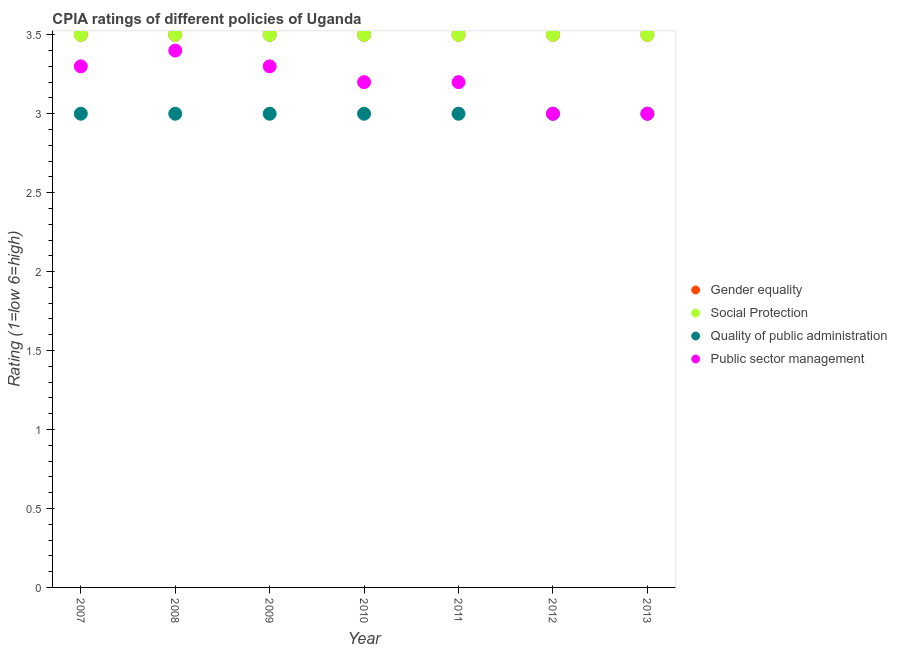In which year was the cpia rating of social protection maximum?
Offer a terse response. 2007. In which year was the cpia rating of social protection minimum?
Make the answer very short. 2007. What is the total cpia rating of quality of public administration in the graph?
Keep it short and to the point. 21. What is the difference between the cpia rating of quality of public administration in 2011 and that in 2012?
Offer a terse response. 0. What is the ratio of the cpia rating of public sector management in 2010 to that in 2011?
Your answer should be very brief. 1. Is the sum of the cpia rating of quality of public administration in 2007 and 2008 greater than the maximum cpia rating of public sector management across all years?
Ensure brevity in your answer.  Yes. Is it the case that in every year, the sum of the cpia rating of social protection and cpia rating of public sector management is greater than the sum of cpia rating of gender equality and cpia rating of quality of public administration?
Provide a short and direct response. No. Is it the case that in every year, the sum of the cpia rating of gender equality and cpia rating of social protection is greater than the cpia rating of quality of public administration?
Offer a terse response. Yes. Is the cpia rating of gender equality strictly less than the cpia rating of public sector management over the years?
Keep it short and to the point. No. What is the difference between two consecutive major ticks on the Y-axis?
Provide a short and direct response. 0.5. How are the legend labels stacked?
Your answer should be compact. Vertical. What is the title of the graph?
Offer a terse response. CPIA ratings of different policies of Uganda. Does "Miscellaneous expenses" appear as one of the legend labels in the graph?
Your response must be concise. No. What is the label or title of the X-axis?
Provide a short and direct response. Year. What is the label or title of the Y-axis?
Keep it short and to the point. Rating (1=low 6=high). What is the Rating (1=low 6=high) in Gender equality in 2008?
Make the answer very short. 3.5. What is the Rating (1=low 6=high) of Quality of public administration in 2008?
Make the answer very short. 3. What is the Rating (1=low 6=high) in Public sector management in 2008?
Provide a short and direct response. 3.4. What is the Rating (1=low 6=high) of Gender equality in 2009?
Provide a short and direct response. 3.5. What is the Rating (1=low 6=high) of Social Protection in 2009?
Provide a succinct answer. 3.5. What is the Rating (1=low 6=high) in Quality of public administration in 2009?
Offer a terse response. 3. What is the Rating (1=low 6=high) in Public sector management in 2009?
Provide a short and direct response. 3.3. What is the Rating (1=low 6=high) of Social Protection in 2010?
Ensure brevity in your answer.  3.5. What is the Rating (1=low 6=high) of Public sector management in 2010?
Provide a short and direct response. 3.2. What is the Rating (1=low 6=high) in Gender equality in 2011?
Provide a succinct answer. 3.5. What is the Rating (1=low 6=high) in Quality of public administration in 2011?
Offer a terse response. 3. What is the Rating (1=low 6=high) in Public sector management in 2011?
Your answer should be compact. 3.2. What is the Rating (1=low 6=high) of Public sector management in 2012?
Give a very brief answer. 3. What is the Rating (1=low 6=high) in Gender equality in 2013?
Provide a short and direct response. 3.5. Across all years, what is the maximum Rating (1=low 6=high) in Gender equality?
Make the answer very short. 3.5. Across all years, what is the maximum Rating (1=low 6=high) in Quality of public administration?
Make the answer very short. 3. Across all years, what is the maximum Rating (1=low 6=high) in Public sector management?
Keep it short and to the point. 3.4. Across all years, what is the minimum Rating (1=low 6=high) of Quality of public administration?
Your response must be concise. 3. Across all years, what is the minimum Rating (1=low 6=high) of Public sector management?
Offer a very short reply. 3. What is the total Rating (1=low 6=high) of Social Protection in the graph?
Provide a short and direct response. 24.5. What is the total Rating (1=low 6=high) of Public sector management in the graph?
Ensure brevity in your answer.  22.4. What is the difference between the Rating (1=low 6=high) of Social Protection in 2007 and that in 2008?
Make the answer very short. 0. What is the difference between the Rating (1=low 6=high) in Quality of public administration in 2007 and that in 2008?
Your response must be concise. 0. What is the difference between the Rating (1=low 6=high) of Gender equality in 2007 and that in 2009?
Offer a very short reply. 0. What is the difference between the Rating (1=low 6=high) of Social Protection in 2007 and that in 2009?
Your response must be concise. 0. What is the difference between the Rating (1=low 6=high) of Social Protection in 2007 and that in 2010?
Offer a very short reply. 0. What is the difference between the Rating (1=low 6=high) in Quality of public administration in 2007 and that in 2010?
Your answer should be compact. 0. What is the difference between the Rating (1=low 6=high) in Public sector management in 2007 and that in 2010?
Your response must be concise. 0.1. What is the difference between the Rating (1=low 6=high) of Gender equality in 2007 and that in 2011?
Offer a very short reply. 0. What is the difference between the Rating (1=low 6=high) of Quality of public administration in 2007 and that in 2011?
Provide a short and direct response. 0. What is the difference between the Rating (1=low 6=high) of Social Protection in 2007 and that in 2012?
Offer a very short reply. 0. What is the difference between the Rating (1=low 6=high) of Public sector management in 2007 and that in 2012?
Keep it short and to the point. 0.3. What is the difference between the Rating (1=low 6=high) of Gender equality in 2008 and that in 2009?
Your answer should be compact. 0. What is the difference between the Rating (1=low 6=high) of Social Protection in 2008 and that in 2009?
Keep it short and to the point. 0. What is the difference between the Rating (1=low 6=high) in Public sector management in 2008 and that in 2009?
Your response must be concise. 0.1. What is the difference between the Rating (1=low 6=high) of Quality of public administration in 2008 and that in 2010?
Give a very brief answer. 0. What is the difference between the Rating (1=low 6=high) of Public sector management in 2008 and that in 2010?
Provide a succinct answer. 0.2. What is the difference between the Rating (1=low 6=high) in Gender equality in 2008 and that in 2011?
Offer a terse response. 0. What is the difference between the Rating (1=low 6=high) of Social Protection in 2008 and that in 2011?
Keep it short and to the point. 0. What is the difference between the Rating (1=low 6=high) in Quality of public administration in 2008 and that in 2011?
Your response must be concise. 0. What is the difference between the Rating (1=low 6=high) of Gender equality in 2008 and that in 2012?
Your response must be concise. 0. What is the difference between the Rating (1=low 6=high) of Social Protection in 2008 and that in 2012?
Keep it short and to the point. 0. What is the difference between the Rating (1=low 6=high) in Social Protection in 2008 and that in 2013?
Provide a short and direct response. 0. What is the difference between the Rating (1=low 6=high) in Gender equality in 2009 and that in 2010?
Your answer should be very brief. 0. What is the difference between the Rating (1=low 6=high) of Social Protection in 2009 and that in 2010?
Your response must be concise. 0. What is the difference between the Rating (1=low 6=high) of Gender equality in 2009 and that in 2011?
Your answer should be compact. 0. What is the difference between the Rating (1=low 6=high) in Social Protection in 2009 and that in 2011?
Ensure brevity in your answer.  0. What is the difference between the Rating (1=low 6=high) in Quality of public administration in 2009 and that in 2011?
Offer a terse response. 0. What is the difference between the Rating (1=low 6=high) in Gender equality in 2009 and that in 2012?
Ensure brevity in your answer.  0. What is the difference between the Rating (1=low 6=high) in Social Protection in 2009 and that in 2012?
Offer a terse response. 0. What is the difference between the Rating (1=low 6=high) of Quality of public administration in 2009 and that in 2012?
Give a very brief answer. 0. What is the difference between the Rating (1=low 6=high) in Gender equality in 2009 and that in 2013?
Your answer should be very brief. 0. What is the difference between the Rating (1=low 6=high) of Public sector management in 2009 and that in 2013?
Give a very brief answer. 0.3. What is the difference between the Rating (1=low 6=high) in Gender equality in 2010 and that in 2011?
Your answer should be compact. 0. What is the difference between the Rating (1=low 6=high) in Social Protection in 2010 and that in 2011?
Keep it short and to the point. 0. What is the difference between the Rating (1=low 6=high) of Public sector management in 2010 and that in 2011?
Your answer should be very brief. 0. What is the difference between the Rating (1=low 6=high) in Gender equality in 2010 and that in 2012?
Provide a short and direct response. 0. What is the difference between the Rating (1=low 6=high) in Social Protection in 2010 and that in 2012?
Offer a terse response. 0. What is the difference between the Rating (1=low 6=high) in Public sector management in 2010 and that in 2012?
Make the answer very short. 0.2. What is the difference between the Rating (1=low 6=high) of Social Protection in 2010 and that in 2013?
Offer a very short reply. 0. What is the difference between the Rating (1=low 6=high) of Public sector management in 2010 and that in 2013?
Offer a terse response. 0.2. What is the difference between the Rating (1=low 6=high) in Gender equality in 2011 and that in 2012?
Your answer should be very brief. 0. What is the difference between the Rating (1=low 6=high) of Social Protection in 2011 and that in 2012?
Keep it short and to the point. 0. What is the difference between the Rating (1=low 6=high) of Quality of public administration in 2011 and that in 2012?
Ensure brevity in your answer.  0. What is the difference between the Rating (1=low 6=high) of Public sector management in 2011 and that in 2012?
Make the answer very short. 0.2. What is the difference between the Rating (1=low 6=high) of Gender equality in 2011 and that in 2013?
Offer a very short reply. 0. What is the difference between the Rating (1=low 6=high) in Social Protection in 2011 and that in 2013?
Your answer should be very brief. 0. What is the difference between the Rating (1=low 6=high) in Public sector management in 2011 and that in 2013?
Your answer should be very brief. 0.2. What is the difference between the Rating (1=low 6=high) in Gender equality in 2012 and that in 2013?
Keep it short and to the point. 0. What is the difference between the Rating (1=low 6=high) in Quality of public administration in 2012 and that in 2013?
Provide a short and direct response. 0. What is the difference between the Rating (1=low 6=high) in Social Protection in 2007 and the Rating (1=low 6=high) in Quality of public administration in 2008?
Give a very brief answer. 0.5. What is the difference between the Rating (1=low 6=high) in Social Protection in 2007 and the Rating (1=low 6=high) in Public sector management in 2008?
Give a very brief answer. 0.1. What is the difference between the Rating (1=low 6=high) of Quality of public administration in 2007 and the Rating (1=low 6=high) of Public sector management in 2008?
Make the answer very short. -0.4. What is the difference between the Rating (1=low 6=high) in Gender equality in 2007 and the Rating (1=low 6=high) in Quality of public administration in 2009?
Give a very brief answer. 0.5. What is the difference between the Rating (1=low 6=high) of Social Protection in 2007 and the Rating (1=low 6=high) of Quality of public administration in 2009?
Offer a terse response. 0.5. What is the difference between the Rating (1=low 6=high) in Gender equality in 2007 and the Rating (1=low 6=high) in Quality of public administration in 2010?
Give a very brief answer. 0.5. What is the difference between the Rating (1=low 6=high) in Social Protection in 2007 and the Rating (1=low 6=high) in Public sector management in 2010?
Offer a very short reply. 0.3. What is the difference between the Rating (1=low 6=high) of Quality of public administration in 2007 and the Rating (1=low 6=high) of Public sector management in 2010?
Provide a succinct answer. -0.2. What is the difference between the Rating (1=low 6=high) of Gender equality in 2007 and the Rating (1=low 6=high) of Quality of public administration in 2011?
Offer a very short reply. 0.5. What is the difference between the Rating (1=low 6=high) in Social Protection in 2007 and the Rating (1=low 6=high) in Public sector management in 2011?
Offer a terse response. 0.3. What is the difference between the Rating (1=low 6=high) in Social Protection in 2007 and the Rating (1=low 6=high) in Quality of public administration in 2012?
Ensure brevity in your answer.  0.5. What is the difference between the Rating (1=low 6=high) in Social Protection in 2007 and the Rating (1=low 6=high) in Public sector management in 2012?
Offer a terse response. 0.5. What is the difference between the Rating (1=low 6=high) of Gender equality in 2007 and the Rating (1=low 6=high) of Social Protection in 2013?
Offer a terse response. 0. What is the difference between the Rating (1=low 6=high) in Gender equality in 2007 and the Rating (1=low 6=high) in Public sector management in 2013?
Your response must be concise. 0.5. What is the difference between the Rating (1=low 6=high) of Quality of public administration in 2007 and the Rating (1=low 6=high) of Public sector management in 2013?
Your answer should be very brief. 0. What is the difference between the Rating (1=low 6=high) in Gender equality in 2008 and the Rating (1=low 6=high) in Social Protection in 2009?
Keep it short and to the point. 0. What is the difference between the Rating (1=low 6=high) of Gender equality in 2008 and the Rating (1=low 6=high) of Quality of public administration in 2009?
Keep it short and to the point. 0.5. What is the difference between the Rating (1=low 6=high) of Gender equality in 2008 and the Rating (1=low 6=high) of Quality of public administration in 2010?
Provide a succinct answer. 0.5. What is the difference between the Rating (1=low 6=high) in Gender equality in 2008 and the Rating (1=low 6=high) in Public sector management in 2010?
Provide a short and direct response. 0.3. What is the difference between the Rating (1=low 6=high) of Social Protection in 2008 and the Rating (1=low 6=high) of Quality of public administration in 2010?
Offer a very short reply. 0.5. What is the difference between the Rating (1=low 6=high) of Quality of public administration in 2008 and the Rating (1=low 6=high) of Public sector management in 2010?
Give a very brief answer. -0.2. What is the difference between the Rating (1=low 6=high) of Gender equality in 2008 and the Rating (1=low 6=high) of Social Protection in 2011?
Your answer should be very brief. 0. What is the difference between the Rating (1=low 6=high) of Gender equality in 2008 and the Rating (1=low 6=high) of Public sector management in 2011?
Keep it short and to the point. 0.3. What is the difference between the Rating (1=low 6=high) of Social Protection in 2008 and the Rating (1=low 6=high) of Quality of public administration in 2011?
Provide a short and direct response. 0.5. What is the difference between the Rating (1=low 6=high) in Social Protection in 2008 and the Rating (1=low 6=high) in Public sector management in 2011?
Your response must be concise. 0.3. What is the difference between the Rating (1=low 6=high) in Gender equality in 2008 and the Rating (1=low 6=high) in Social Protection in 2012?
Offer a very short reply. 0. What is the difference between the Rating (1=low 6=high) of Gender equality in 2008 and the Rating (1=low 6=high) of Quality of public administration in 2012?
Ensure brevity in your answer.  0.5. What is the difference between the Rating (1=low 6=high) in Gender equality in 2008 and the Rating (1=low 6=high) in Public sector management in 2012?
Offer a very short reply. 0.5. What is the difference between the Rating (1=low 6=high) in Social Protection in 2008 and the Rating (1=low 6=high) in Public sector management in 2012?
Your answer should be very brief. 0.5. What is the difference between the Rating (1=low 6=high) of Quality of public administration in 2008 and the Rating (1=low 6=high) of Public sector management in 2012?
Offer a terse response. 0. What is the difference between the Rating (1=low 6=high) in Gender equality in 2008 and the Rating (1=low 6=high) in Quality of public administration in 2013?
Provide a short and direct response. 0.5. What is the difference between the Rating (1=low 6=high) of Gender equality in 2008 and the Rating (1=low 6=high) of Public sector management in 2013?
Provide a succinct answer. 0.5. What is the difference between the Rating (1=low 6=high) of Social Protection in 2008 and the Rating (1=low 6=high) of Public sector management in 2013?
Make the answer very short. 0.5. What is the difference between the Rating (1=low 6=high) of Quality of public administration in 2008 and the Rating (1=low 6=high) of Public sector management in 2013?
Your answer should be compact. 0. What is the difference between the Rating (1=low 6=high) in Gender equality in 2009 and the Rating (1=low 6=high) in Social Protection in 2010?
Offer a terse response. 0. What is the difference between the Rating (1=low 6=high) of Gender equality in 2009 and the Rating (1=low 6=high) of Quality of public administration in 2010?
Provide a succinct answer. 0.5. What is the difference between the Rating (1=low 6=high) of Gender equality in 2009 and the Rating (1=low 6=high) of Public sector management in 2010?
Provide a short and direct response. 0.3. What is the difference between the Rating (1=low 6=high) of Social Protection in 2009 and the Rating (1=low 6=high) of Public sector management in 2010?
Offer a terse response. 0.3. What is the difference between the Rating (1=low 6=high) of Gender equality in 2009 and the Rating (1=low 6=high) of Social Protection in 2011?
Your answer should be very brief. 0. What is the difference between the Rating (1=low 6=high) in Gender equality in 2009 and the Rating (1=low 6=high) in Quality of public administration in 2011?
Offer a very short reply. 0.5. What is the difference between the Rating (1=low 6=high) of Gender equality in 2009 and the Rating (1=low 6=high) of Public sector management in 2011?
Offer a very short reply. 0.3. What is the difference between the Rating (1=low 6=high) of Social Protection in 2009 and the Rating (1=low 6=high) of Quality of public administration in 2011?
Provide a short and direct response. 0.5. What is the difference between the Rating (1=low 6=high) of Gender equality in 2009 and the Rating (1=low 6=high) of Public sector management in 2012?
Make the answer very short. 0.5. What is the difference between the Rating (1=low 6=high) in Social Protection in 2009 and the Rating (1=low 6=high) in Quality of public administration in 2012?
Make the answer very short. 0.5. What is the difference between the Rating (1=low 6=high) in Social Protection in 2009 and the Rating (1=low 6=high) in Quality of public administration in 2013?
Ensure brevity in your answer.  0.5. What is the difference between the Rating (1=low 6=high) in Gender equality in 2010 and the Rating (1=low 6=high) in Public sector management in 2011?
Your answer should be very brief. 0.3. What is the difference between the Rating (1=low 6=high) of Social Protection in 2010 and the Rating (1=low 6=high) of Public sector management in 2011?
Your answer should be very brief. 0.3. What is the difference between the Rating (1=low 6=high) of Gender equality in 2010 and the Rating (1=low 6=high) of Social Protection in 2012?
Your answer should be very brief. 0. What is the difference between the Rating (1=low 6=high) of Gender equality in 2010 and the Rating (1=low 6=high) of Quality of public administration in 2012?
Your answer should be very brief. 0.5. What is the difference between the Rating (1=low 6=high) of Social Protection in 2010 and the Rating (1=low 6=high) of Quality of public administration in 2012?
Your answer should be compact. 0.5. What is the difference between the Rating (1=low 6=high) of Social Protection in 2010 and the Rating (1=low 6=high) of Public sector management in 2012?
Your answer should be very brief. 0.5. What is the difference between the Rating (1=low 6=high) in Gender equality in 2010 and the Rating (1=low 6=high) in Quality of public administration in 2013?
Your answer should be very brief. 0.5. What is the difference between the Rating (1=low 6=high) of Social Protection in 2010 and the Rating (1=low 6=high) of Public sector management in 2013?
Your answer should be compact. 0.5. What is the difference between the Rating (1=low 6=high) in Gender equality in 2011 and the Rating (1=low 6=high) in Public sector management in 2012?
Make the answer very short. 0.5. What is the difference between the Rating (1=low 6=high) in Social Protection in 2011 and the Rating (1=low 6=high) in Quality of public administration in 2012?
Give a very brief answer. 0.5. What is the difference between the Rating (1=low 6=high) in Social Protection in 2011 and the Rating (1=low 6=high) in Public sector management in 2013?
Provide a short and direct response. 0.5. What is the difference between the Rating (1=low 6=high) of Quality of public administration in 2011 and the Rating (1=low 6=high) of Public sector management in 2013?
Make the answer very short. 0. What is the difference between the Rating (1=low 6=high) in Gender equality in 2012 and the Rating (1=low 6=high) in Social Protection in 2013?
Offer a very short reply. 0. What is the difference between the Rating (1=low 6=high) in Social Protection in 2012 and the Rating (1=low 6=high) in Quality of public administration in 2013?
Make the answer very short. 0.5. What is the difference between the Rating (1=low 6=high) of Quality of public administration in 2012 and the Rating (1=low 6=high) of Public sector management in 2013?
Give a very brief answer. 0. What is the average Rating (1=low 6=high) in Social Protection per year?
Keep it short and to the point. 3.5. What is the average Rating (1=low 6=high) of Quality of public administration per year?
Your answer should be compact. 3. In the year 2007, what is the difference between the Rating (1=low 6=high) of Gender equality and Rating (1=low 6=high) of Social Protection?
Provide a short and direct response. 0. In the year 2007, what is the difference between the Rating (1=low 6=high) in Gender equality and Rating (1=low 6=high) in Public sector management?
Your answer should be very brief. 0.2. In the year 2007, what is the difference between the Rating (1=low 6=high) in Social Protection and Rating (1=low 6=high) in Quality of public administration?
Offer a very short reply. 0.5. In the year 2007, what is the difference between the Rating (1=low 6=high) of Social Protection and Rating (1=low 6=high) of Public sector management?
Give a very brief answer. 0.2. In the year 2007, what is the difference between the Rating (1=low 6=high) of Quality of public administration and Rating (1=low 6=high) of Public sector management?
Your response must be concise. -0.3. In the year 2008, what is the difference between the Rating (1=low 6=high) in Gender equality and Rating (1=low 6=high) in Public sector management?
Provide a succinct answer. 0.1. In the year 2008, what is the difference between the Rating (1=low 6=high) of Social Protection and Rating (1=low 6=high) of Quality of public administration?
Give a very brief answer. 0.5. In the year 2008, what is the difference between the Rating (1=low 6=high) in Quality of public administration and Rating (1=low 6=high) in Public sector management?
Offer a terse response. -0.4. In the year 2009, what is the difference between the Rating (1=low 6=high) of Gender equality and Rating (1=low 6=high) of Social Protection?
Your answer should be very brief. 0. In the year 2009, what is the difference between the Rating (1=low 6=high) in Gender equality and Rating (1=low 6=high) in Quality of public administration?
Provide a succinct answer. 0.5. In the year 2009, what is the difference between the Rating (1=low 6=high) in Gender equality and Rating (1=low 6=high) in Public sector management?
Your answer should be very brief. 0.2. In the year 2009, what is the difference between the Rating (1=low 6=high) in Social Protection and Rating (1=low 6=high) in Quality of public administration?
Keep it short and to the point. 0.5. In the year 2009, what is the difference between the Rating (1=low 6=high) of Quality of public administration and Rating (1=low 6=high) of Public sector management?
Keep it short and to the point. -0.3. In the year 2010, what is the difference between the Rating (1=low 6=high) in Gender equality and Rating (1=low 6=high) in Social Protection?
Your response must be concise. 0. In the year 2010, what is the difference between the Rating (1=low 6=high) of Gender equality and Rating (1=low 6=high) of Public sector management?
Provide a short and direct response. 0.3. In the year 2010, what is the difference between the Rating (1=low 6=high) of Social Protection and Rating (1=low 6=high) of Quality of public administration?
Offer a terse response. 0.5. In the year 2010, what is the difference between the Rating (1=low 6=high) of Social Protection and Rating (1=low 6=high) of Public sector management?
Offer a terse response. 0.3. In the year 2011, what is the difference between the Rating (1=low 6=high) of Gender equality and Rating (1=low 6=high) of Public sector management?
Provide a succinct answer. 0.3. In the year 2011, what is the difference between the Rating (1=low 6=high) of Social Protection and Rating (1=low 6=high) of Public sector management?
Give a very brief answer. 0.3. In the year 2012, what is the difference between the Rating (1=low 6=high) in Gender equality and Rating (1=low 6=high) in Social Protection?
Make the answer very short. 0. In the year 2012, what is the difference between the Rating (1=low 6=high) of Gender equality and Rating (1=low 6=high) of Public sector management?
Your answer should be very brief. 0.5. In the year 2012, what is the difference between the Rating (1=low 6=high) in Social Protection and Rating (1=low 6=high) in Quality of public administration?
Offer a very short reply. 0.5. In the year 2013, what is the difference between the Rating (1=low 6=high) of Social Protection and Rating (1=low 6=high) of Quality of public administration?
Give a very brief answer. 0.5. In the year 2013, what is the difference between the Rating (1=low 6=high) in Social Protection and Rating (1=low 6=high) in Public sector management?
Provide a succinct answer. 0.5. What is the ratio of the Rating (1=low 6=high) in Gender equality in 2007 to that in 2008?
Provide a short and direct response. 1. What is the ratio of the Rating (1=low 6=high) in Social Protection in 2007 to that in 2008?
Your response must be concise. 1. What is the ratio of the Rating (1=low 6=high) in Quality of public administration in 2007 to that in 2008?
Provide a succinct answer. 1. What is the ratio of the Rating (1=low 6=high) of Public sector management in 2007 to that in 2008?
Keep it short and to the point. 0.97. What is the ratio of the Rating (1=low 6=high) in Social Protection in 2007 to that in 2009?
Ensure brevity in your answer.  1. What is the ratio of the Rating (1=low 6=high) of Quality of public administration in 2007 to that in 2009?
Offer a terse response. 1. What is the ratio of the Rating (1=low 6=high) of Gender equality in 2007 to that in 2010?
Provide a succinct answer. 1. What is the ratio of the Rating (1=low 6=high) in Social Protection in 2007 to that in 2010?
Make the answer very short. 1. What is the ratio of the Rating (1=low 6=high) in Public sector management in 2007 to that in 2010?
Keep it short and to the point. 1.03. What is the ratio of the Rating (1=low 6=high) in Gender equality in 2007 to that in 2011?
Offer a very short reply. 1. What is the ratio of the Rating (1=low 6=high) in Public sector management in 2007 to that in 2011?
Offer a terse response. 1.03. What is the ratio of the Rating (1=low 6=high) in Social Protection in 2007 to that in 2012?
Provide a succinct answer. 1. What is the ratio of the Rating (1=low 6=high) in Quality of public administration in 2007 to that in 2012?
Provide a short and direct response. 1. What is the ratio of the Rating (1=low 6=high) of Social Protection in 2007 to that in 2013?
Your answer should be very brief. 1. What is the ratio of the Rating (1=low 6=high) of Public sector management in 2007 to that in 2013?
Your response must be concise. 1.1. What is the ratio of the Rating (1=low 6=high) of Gender equality in 2008 to that in 2009?
Offer a very short reply. 1. What is the ratio of the Rating (1=low 6=high) of Quality of public administration in 2008 to that in 2009?
Provide a succinct answer. 1. What is the ratio of the Rating (1=low 6=high) of Public sector management in 2008 to that in 2009?
Your answer should be compact. 1.03. What is the ratio of the Rating (1=low 6=high) of Gender equality in 2008 to that in 2011?
Provide a succinct answer. 1. What is the ratio of the Rating (1=low 6=high) in Quality of public administration in 2008 to that in 2011?
Your response must be concise. 1. What is the ratio of the Rating (1=low 6=high) in Public sector management in 2008 to that in 2012?
Your answer should be compact. 1.13. What is the ratio of the Rating (1=low 6=high) in Gender equality in 2008 to that in 2013?
Offer a terse response. 1. What is the ratio of the Rating (1=low 6=high) of Public sector management in 2008 to that in 2013?
Your answer should be very brief. 1.13. What is the ratio of the Rating (1=low 6=high) of Gender equality in 2009 to that in 2010?
Your answer should be very brief. 1. What is the ratio of the Rating (1=low 6=high) of Public sector management in 2009 to that in 2010?
Ensure brevity in your answer.  1.03. What is the ratio of the Rating (1=low 6=high) in Gender equality in 2009 to that in 2011?
Give a very brief answer. 1. What is the ratio of the Rating (1=low 6=high) of Social Protection in 2009 to that in 2011?
Provide a short and direct response. 1. What is the ratio of the Rating (1=low 6=high) of Public sector management in 2009 to that in 2011?
Your response must be concise. 1.03. What is the ratio of the Rating (1=low 6=high) in Gender equality in 2009 to that in 2012?
Offer a terse response. 1. What is the ratio of the Rating (1=low 6=high) of Social Protection in 2009 to that in 2012?
Offer a terse response. 1. What is the ratio of the Rating (1=low 6=high) in Public sector management in 2009 to that in 2013?
Your answer should be very brief. 1.1. What is the ratio of the Rating (1=low 6=high) of Gender equality in 2010 to that in 2011?
Provide a short and direct response. 1. What is the ratio of the Rating (1=low 6=high) of Social Protection in 2010 to that in 2011?
Ensure brevity in your answer.  1. What is the ratio of the Rating (1=low 6=high) of Public sector management in 2010 to that in 2011?
Your answer should be very brief. 1. What is the ratio of the Rating (1=low 6=high) in Social Protection in 2010 to that in 2012?
Keep it short and to the point. 1. What is the ratio of the Rating (1=low 6=high) of Public sector management in 2010 to that in 2012?
Offer a terse response. 1.07. What is the ratio of the Rating (1=low 6=high) of Gender equality in 2010 to that in 2013?
Your response must be concise. 1. What is the ratio of the Rating (1=low 6=high) of Quality of public administration in 2010 to that in 2013?
Give a very brief answer. 1. What is the ratio of the Rating (1=low 6=high) of Public sector management in 2010 to that in 2013?
Provide a short and direct response. 1.07. What is the ratio of the Rating (1=low 6=high) in Quality of public administration in 2011 to that in 2012?
Offer a very short reply. 1. What is the ratio of the Rating (1=low 6=high) in Public sector management in 2011 to that in 2012?
Offer a very short reply. 1.07. What is the ratio of the Rating (1=low 6=high) in Public sector management in 2011 to that in 2013?
Provide a short and direct response. 1.07. What is the difference between the highest and the second highest Rating (1=low 6=high) in Gender equality?
Offer a terse response. 0. What is the difference between the highest and the second highest Rating (1=low 6=high) of Public sector management?
Your response must be concise. 0.1. 